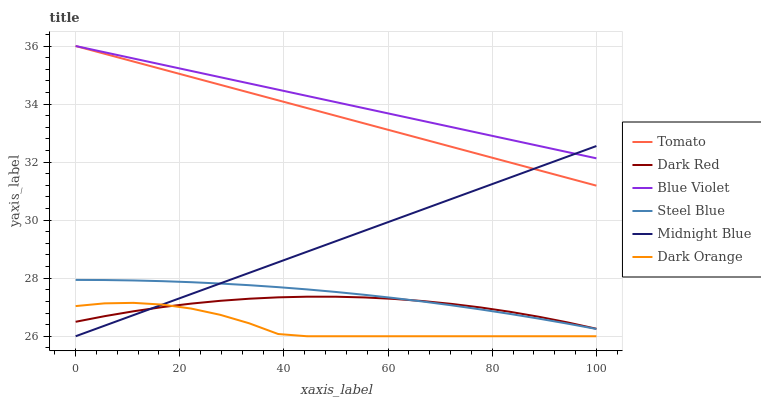Does Dark Orange have the minimum area under the curve?
Answer yes or no. Yes. Does Blue Violet have the maximum area under the curve?
Answer yes or no. Yes. Does Midnight Blue have the minimum area under the curve?
Answer yes or no. No. Does Midnight Blue have the maximum area under the curve?
Answer yes or no. No. Is Blue Violet the smoothest?
Answer yes or no. Yes. Is Dark Orange the roughest?
Answer yes or no. Yes. Is Midnight Blue the smoothest?
Answer yes or no. No. Is Midnight Blue the roughest?
Answer yes or no. No. Does Dark Red have the lowest value?
Answer yes or no. No. Does Blue Violet have the highest value?
Answer yes or no. Yes. Does Midnight Blue have the highest value?
Answer yes or no. No. Is Dark Orange less than Tomato?
Answer yes or no. Yes. Is Blue Violet greater than Dark Red?
Answer yes or no. Yes. Does Midnight Blue intersect Blue Violet?
Answer yes or no. Yes. Is Midnight Blue less than Blue Violet?
Answer yes or no. No. Is Midnight Blue greater than Blue Violet?
Answer yes or no. No. Does Dark Orange intersect Tomato?
Answer yes or no. No. 